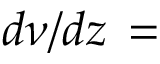Convert formula to latex. <formula><loc_0><loc_0><loc_500><loc_500>d \nu / d z \, =</formula> 